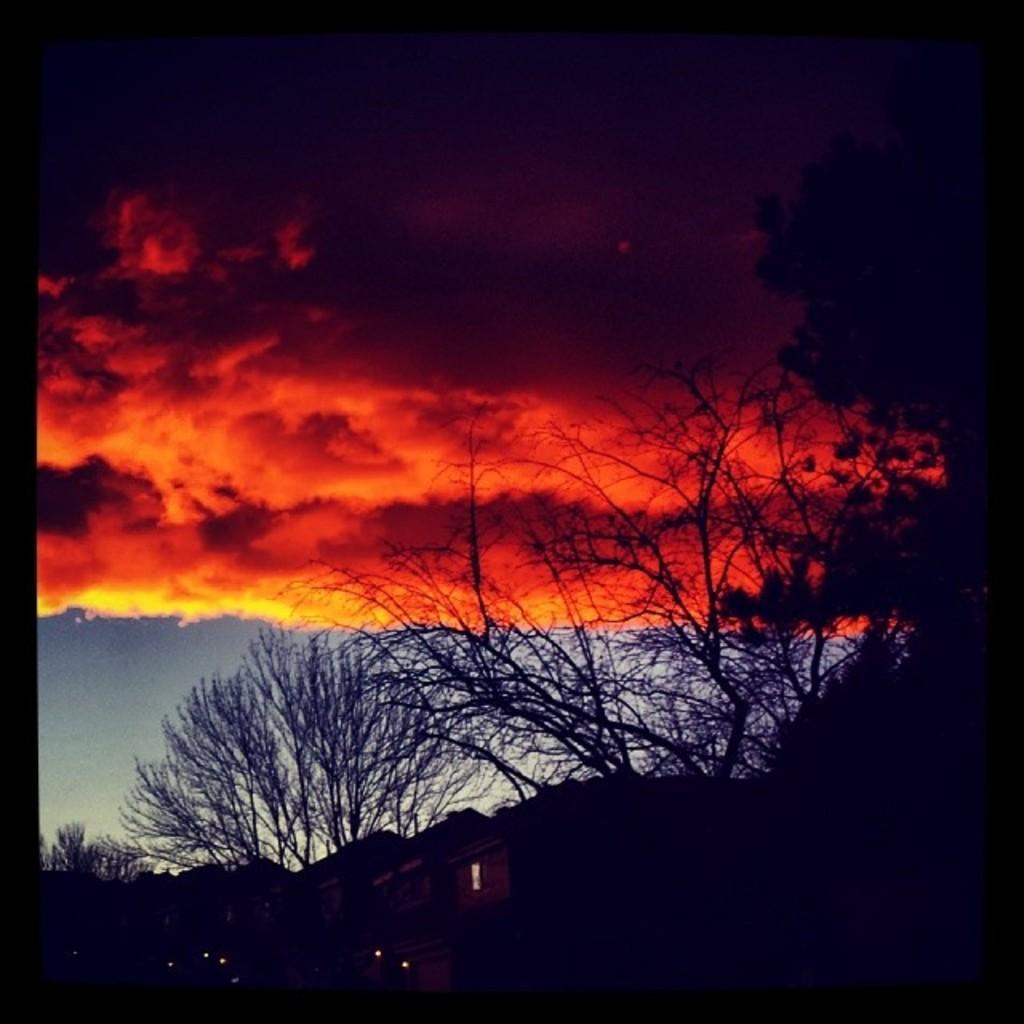What type of vegetation can be seen in the image? There are trees in the image. What type of structures are visible in the image? There are houses in the image. What is visible in the sky in the image? The sky is visible in the image. What can be observed in the sky in the image? Clouds are present in the sky. What type of stocking is hanging from the tree in the image? There is no stocking hanging from the tree in the image; only trees and houses are present. How many quarters are visible on the roof of the houses in the image? There are no quarters visible on the roofs of the houses in the image. 